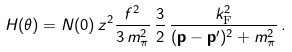<formula> <loc_0><loc_0><loc_500><loc_500>H ( \theta ) = N ( 0 ) \, z ^ { 2 } \frac { f ^ { 2 } } { 3 \, m _ { \pi } ^ { 2 } } \, \frac { 3 } { 2 } \, \frac { k _ { \text {F} } ^ { 2 } } { ( { \mathbf p } - { \mathbf p ^ { \prime } } ) ^ { 2 } + m ^ { 2 } _ { \pi } } \, .</formula> 